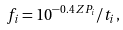Convert formula to latex. <formula><loc_0><loc_0><loc_500><loc_500>f _ { i } = 1 0 ^ { - 0 . 4 \, Z P _ { i } } / t _ { i } ,</formula> 